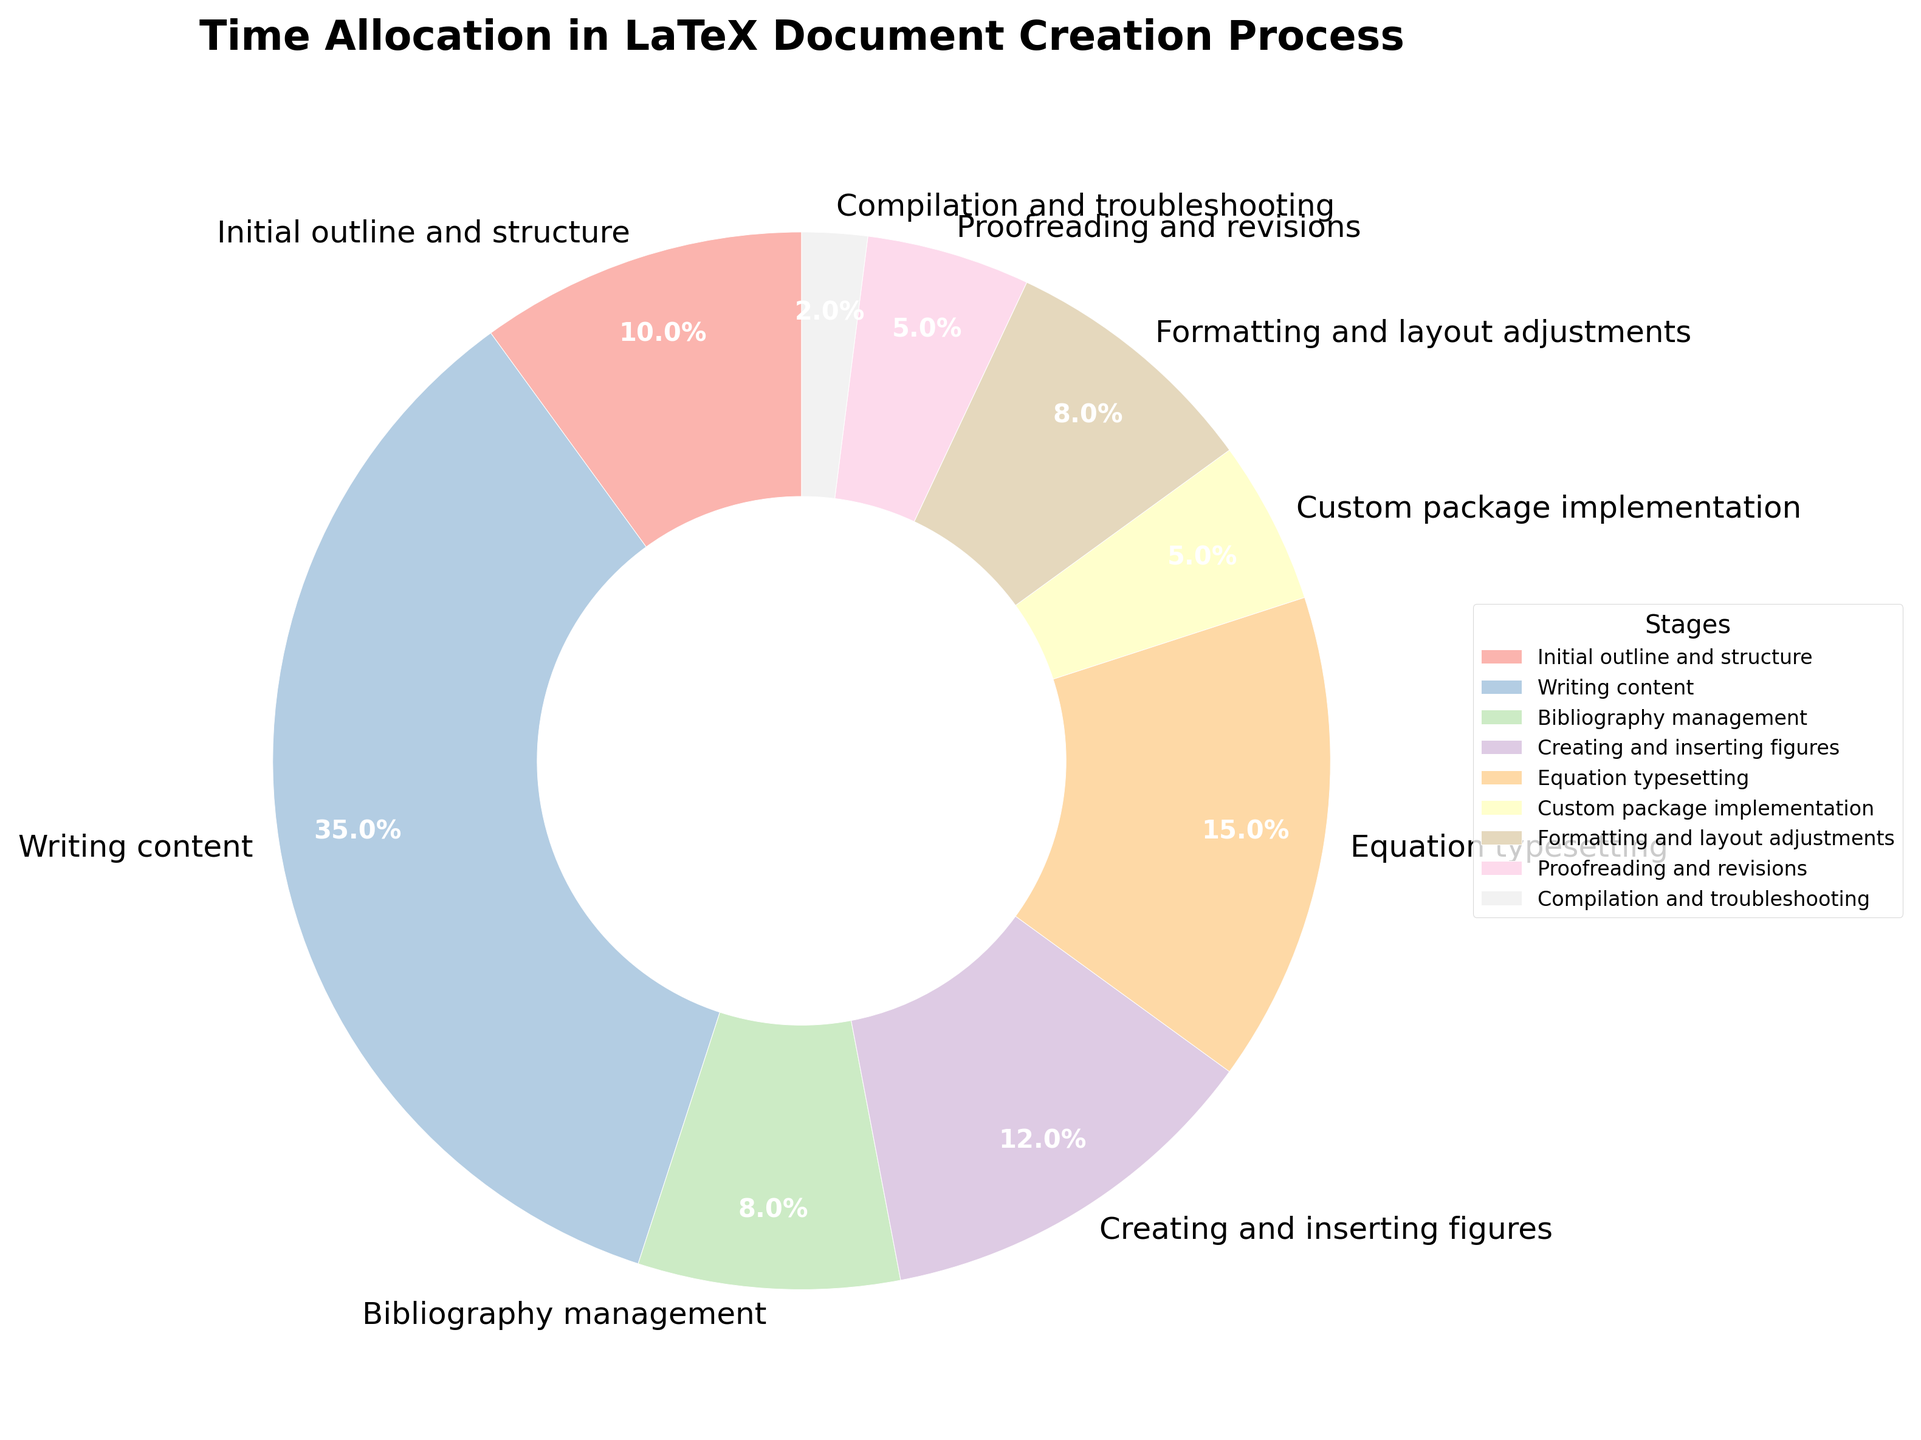What percentage of time is allocated to writing content? To find this, simply locate the "Writing content" section in the pie chart and note the corresponding percentage.
Answer: 35% How much more time is spent on creating and inserting figures compared to custom package implementation? Locate the sections for "Creating and inserting figures" and "Custom package implementation" in the pie chart, then subtract the percentage of the custom package implementation from the percentage of creating and inserting figures (12% - 5% = 7%).
Answer: 7% Which stage takes the least amount of time? Find the smallest segment in the pie chart. "Compilation and troubleshooting" is the smallest, indicating the least time allocated.
Answer: Compilation and troubleshooting What is the total time spent on equation typesetting and formatting and layout adjustments combined? Sum the percentages of "Equation typesetting" (15%) and "Formatting and layout adjustments" (8%). The total is 15% + 8% = 23%.
Answer: 23% Rank the stages in descending order of time allocation. Order the stages based on the sizes of their corresponding segments in the pie chart from largest to smallest: Writing content (35%), Equation typesetting (15%), Creating and inserting figures (12%), Initial outline and structure (10%), Bibliography management (8%), Formatting and layout adjustments (8%), Custom package implementation (5%), Proofreading and revisions (5%), Compilation and troubleshooting (2%).
Answer: Writing content, Equation typesetting, Creating and inserting figures, Initial outline and structure, Bibliography management, Formatting and layout adjustments, Custom package implementation, Proofreading and revisions, Compilation and troubleshooting What is the difference in time allocation between the two stages with the highest percentages? The highest percentage is "Writing content" (35%) and the second highest is "Equation typesetting" (15%). Subtract the smaller from the larger (35% - 15% = 20%).
Answer: 20% What combined time percentage is allocated to the introductory stages (Initial outline and structure, Writing content, Bibliography management)? Sum the percentages of "Initial outline and structure" (10%), "Writing content" (35%), and "Bibliography management" (8%). The total is 10% + 35% + 8% = 53%.
Answer: 53% Which color represents the stage with the highest time allocation? Identify the segment with the largest portion in the pie chart, which is "Writing content". Note the color of this segment, which is one of the pastel colors used (likely the first one among Pastel1 colormap). Describe it as per the visible shade in the chart (e.g., light pink).
Answer: light pink Are the times allocated to creating and inserting figures and formatting and layout adjustments the same? Compare the sizes of the segments for "Creating and inserting figures" (12%) and "Formatting and layout adjustments" (8%). They are not the same.
Answer: No What is the average time spent on proofreading and revisions and custom package implementation? Sum the percentages of "Proofreading and revisions" (5%) and "Custom package implementation" (5%), then divide by 2 to find the average ( (5% + 5%) / 2 = 5%).
Answer: 5% 